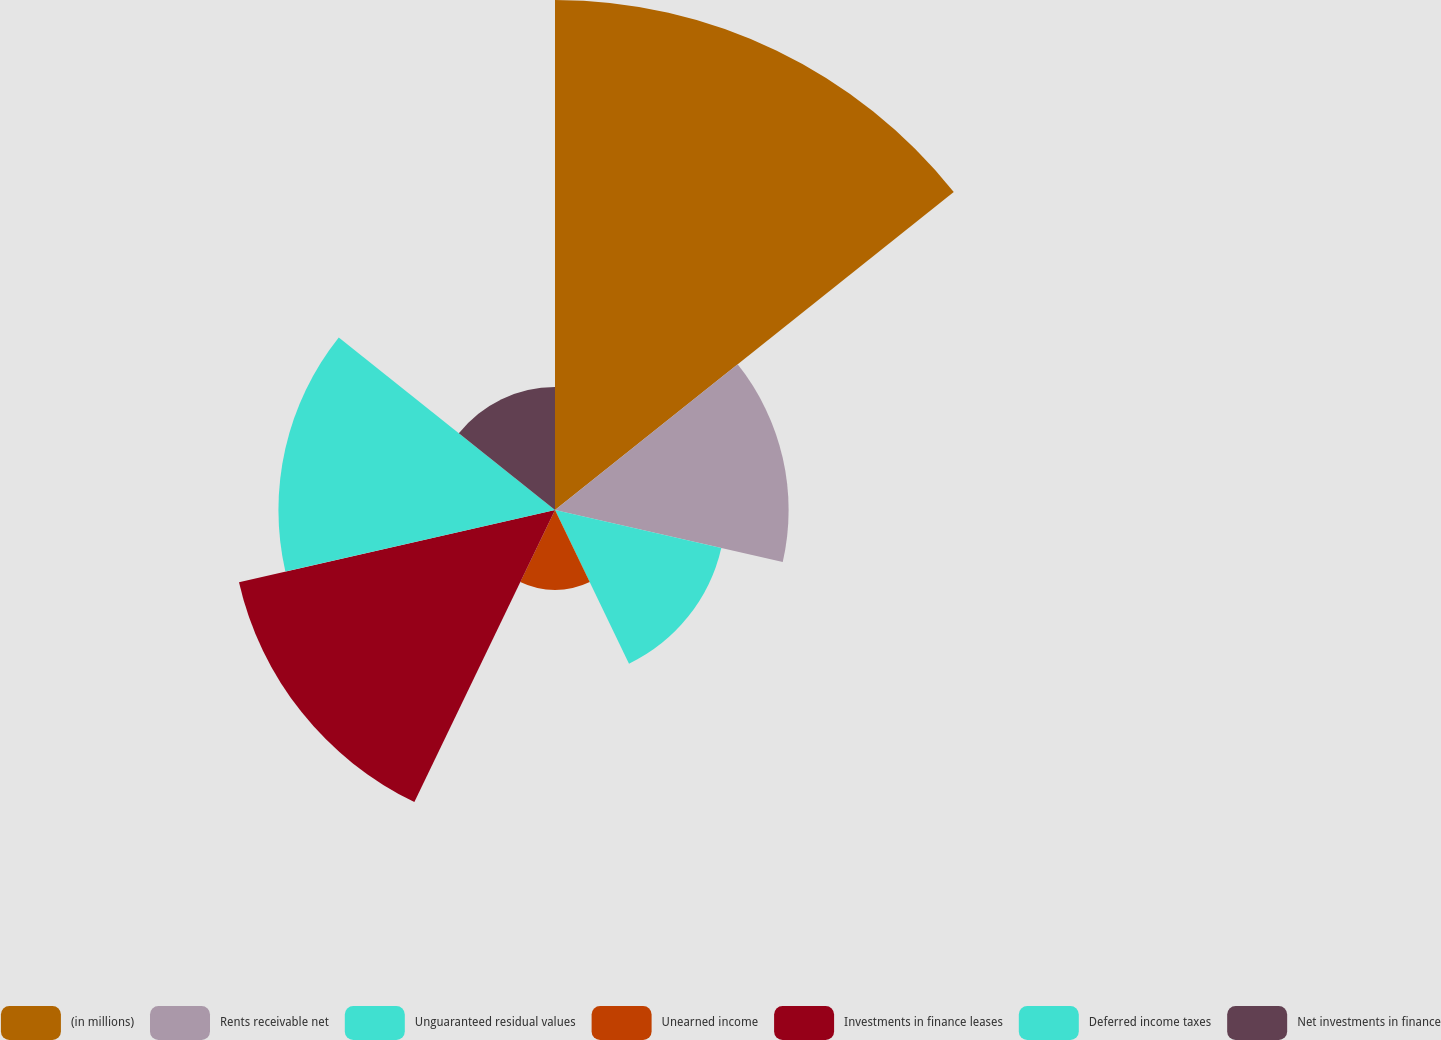Convert chart to OTSL. <chart><loc_0><loc_0><loc_500><loc_500><pie_chart><fcel>(in millions)<fcel>Rents receivable net<fcel>Unguaranteed residual values<fcel>Unearned income<fcel>Investments in finance leases<fcel>Deferred income taxes<fcel>Net investments in finance<nl><fcel>29.69%<fcel>13.6%<fcel>9.93%<fcel>4.66%<fcel>18.87%<fcel>16.1%<fcel>7.16%<nl></chart> 